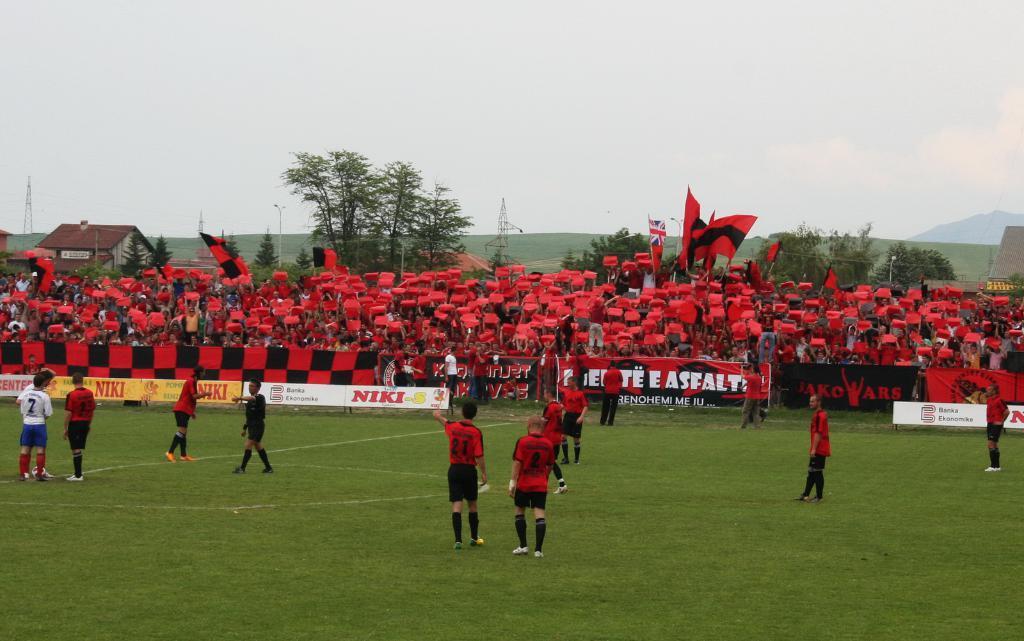Can you describe this image briefly? In this image we can see few persons are standing and walking on the grass on the ground and there is a ball also. In the background there are banners, hoardings, audience holding red color clothes and hoarding. In the background we can see flags, houses, trees, mountain and clouds in the sky. 